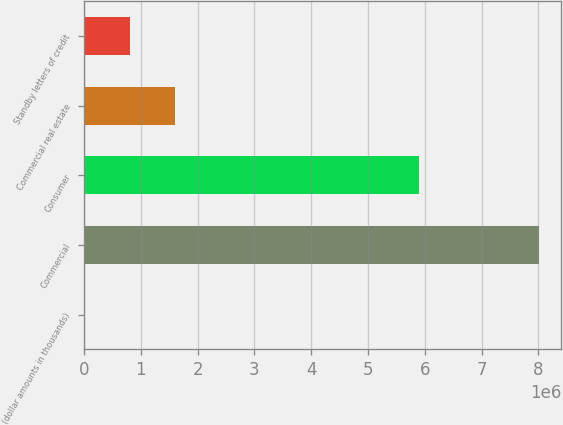<chart> <loc_0><loc_0><loc_500><loc_500><bar_chart><fcel>(dollar amounts in thousands)<fcel>Commercial<fcel>Consumer<fcel>Commercial real estate<fcel>Standby letters of credit<nl><fcel>2011<fcel>8.00607e+06<fcel>5.90384e+06<fcel>1.60282e+06<fcel>802417<nl></chart> 